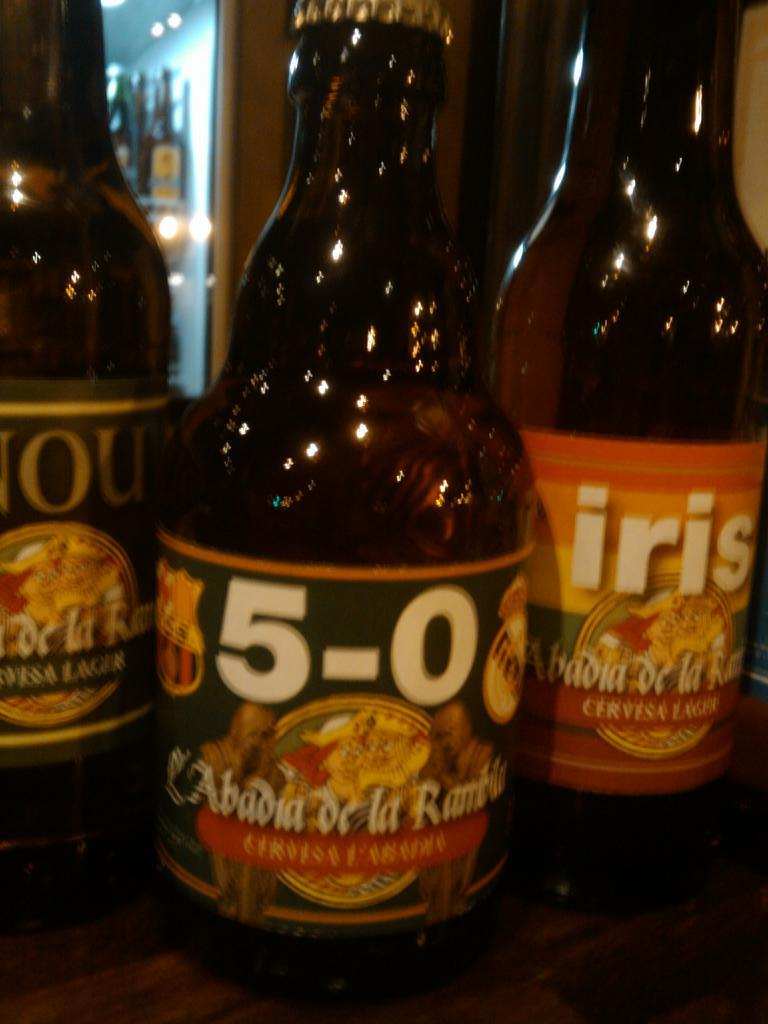<image>
Relay a brief, clear account of the picture shown. Different bottles of beer are displaying with names like 5-0 and iris. 